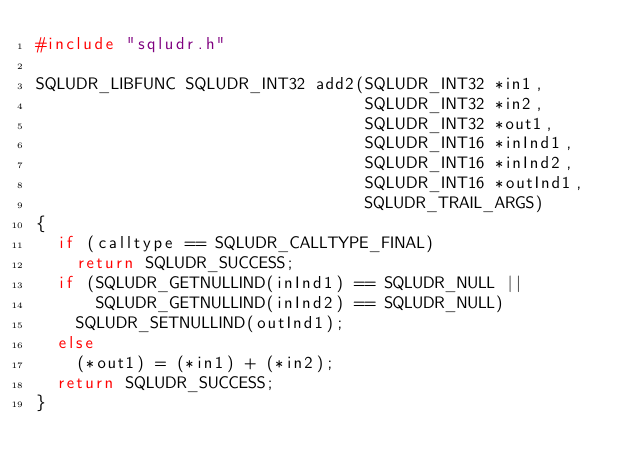Convert code to text. <code><loc_0><loc_0><loc_500><loc_500><_C++_>#include "sqludr.h"

SQLUDR_LIBFUNC SQLUDR_INT32 add2(SQLUDR_INT32 *in1,
                                 SQLUDR_INT32 *in2,
                                 SQLUDR_INT32 *out1,
                                 SQLUDR_INT16 *inInd1,
                                 SQLUDR_INT16 *inInd2,
                                 SQLUDR_INT16 *outInd1,
                                 SQLUDR_TRAIL_ARGS)
{
  if (calltype == SQLUDR_CALLTYPE_FINAL)
    return SQLUDR_SUCCESS;
  if (SQLUDR_GETNULLIND(inInd1) == SQLUDR_NULL ||
      SQLUDR_GETNULLIND(inInd2) == SQLUDR_NULL)
    SQLUDR_SETNULLIND(outInd1);
  else
    (*out1) = (*in1) + (*in2);
  return SQLUDR_SUCCESS;
}

</code> 